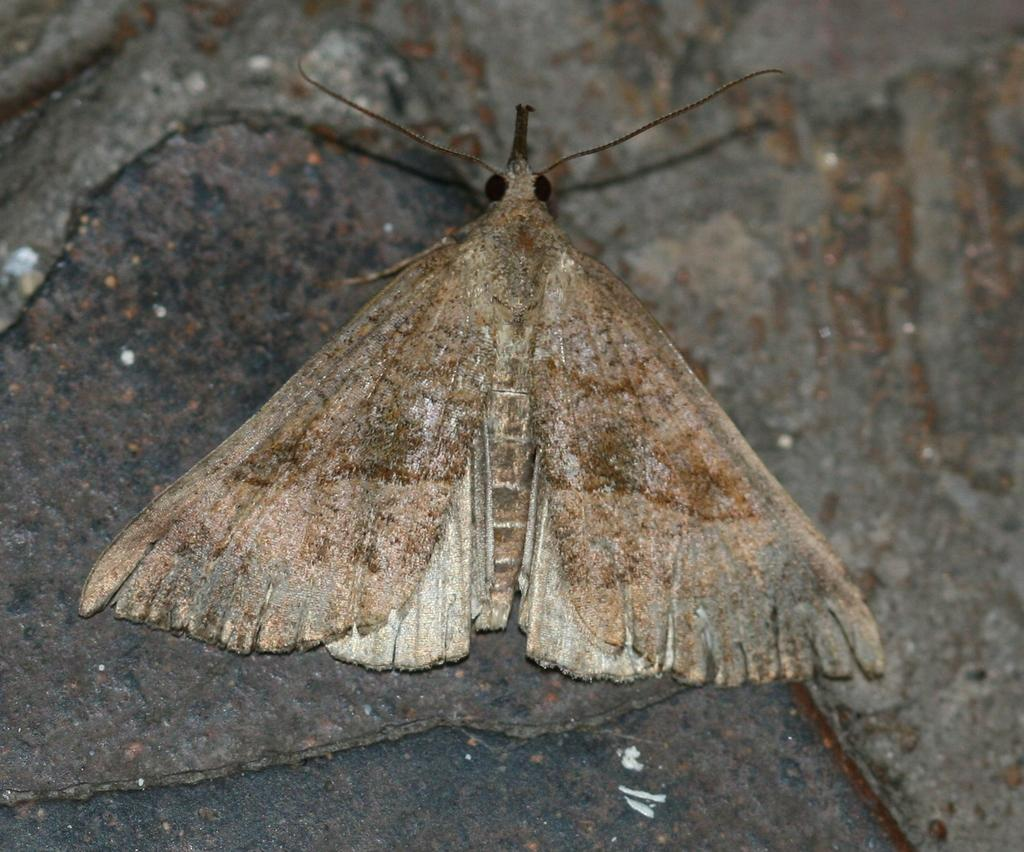What type of insect can be seen in the image? There is a fly in the image. What type of smoke can be seen coming from the plane in the image? There is no plane or smoke present in the image; it only features a fly. 